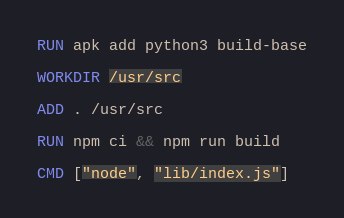Convert code to text. <code><loc_0><loc_0><loc_500><loc_500><_Dockerfile_>
RUN apk add python3 build-base

WORKDIR /usr/src

ADD . /usr/src

RUN npm ci && npm run build

CMD ["node", "lib/index.js"]
</code> 